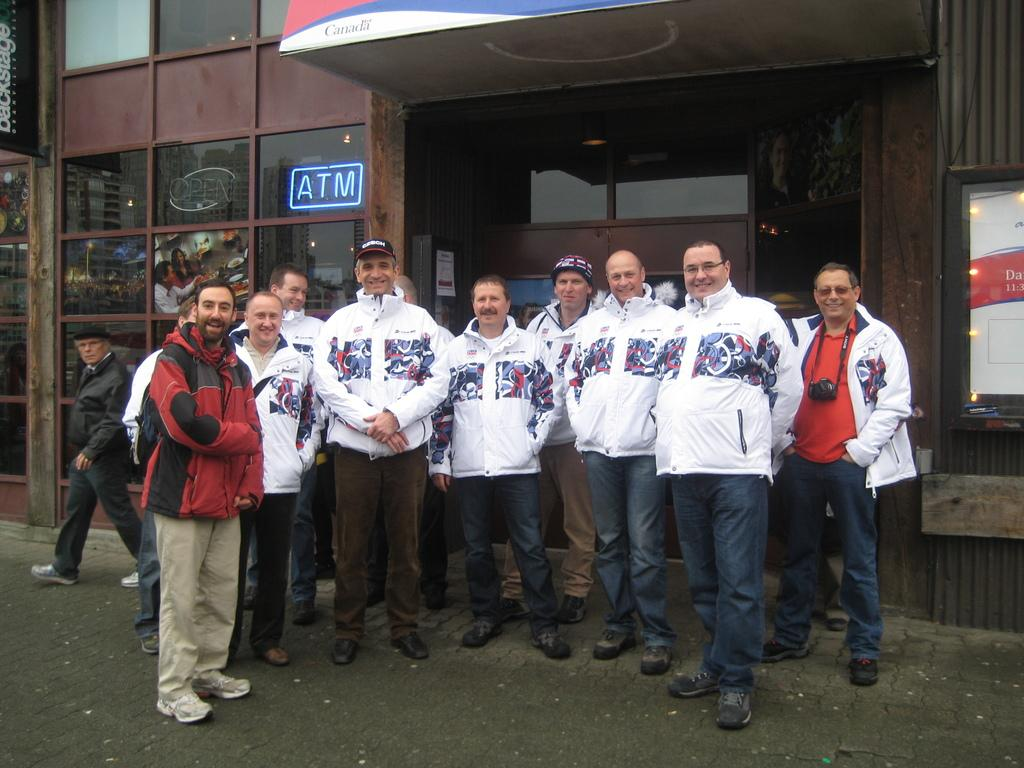<image>
Share a concise interpretation of the image provided. Men standing in front of a building with an atm 